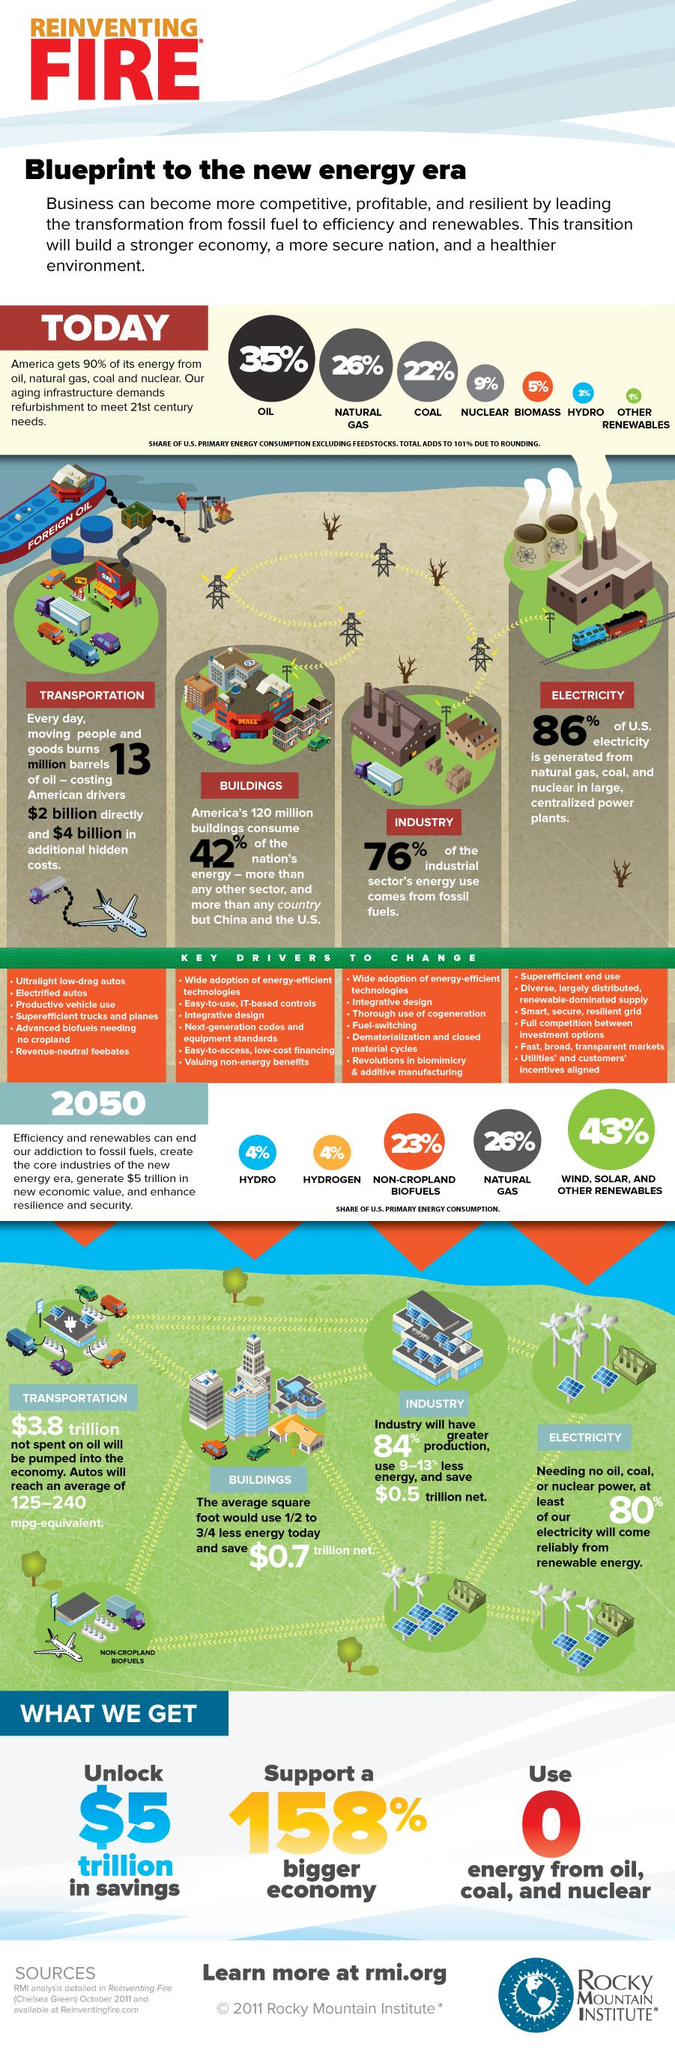Identify some key points in this picture. According to data, 49% of primary fuel consumption in the United States comes from non-cropland biofuels and natural gas. In America, approximately 61% of the energy consumed comes from oil and natural gas. 